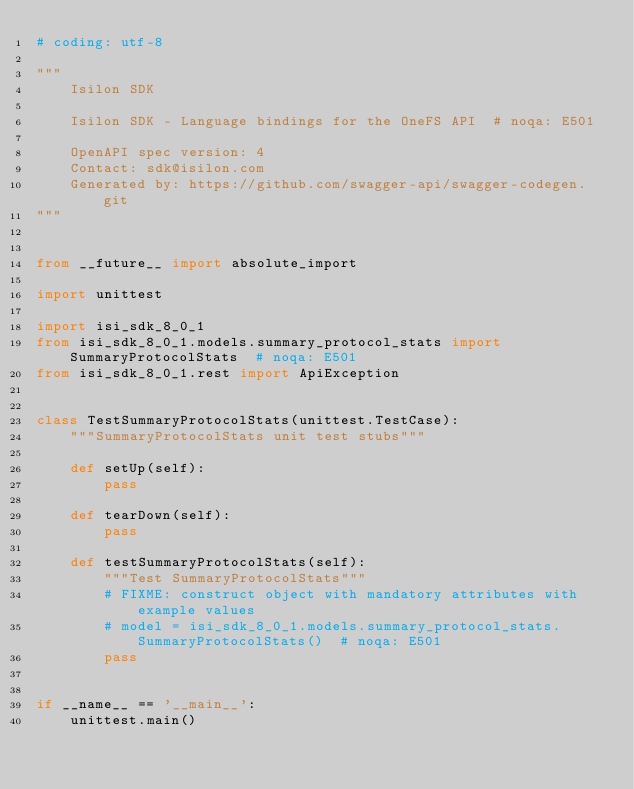Convert code to text. <code><loc_0><loc_0><loc_500><loc_500><_Python_># coding: utf-8

"""
    Isilon SDK

    Isilon SDK - Language bindings for the OneFS API  # noqa: E501

    OpenAPI spec version: 4
    Contact: sdk@isilon.com
    Generated by: https://github.com/swagger-api/swagger-codegen.git
"""


from __future__ import absolute_import

import unittest

import isi_sdk_8_0_1
from isi_sdk_8_0_1.models.summary_protocol_stats import SummaryProtocolStats  # noqa: E501
from isi_sdk_8_0_1.rest import ApiException


class TestSummaryProtocolStats(unittest.TestCase):
    """SummaryProtocolStats unit test stubs"""

    def setUp(self):
        pass

    def tearDown(self):
        pass

    def testSummaryProtocolStats(self):
        """Test SummaryProtocolStats"""
        # FIXME: construct object with mandatory attributes with example values
        # model = isi_sdk_8_0_1.models.summary_protocol_stats.SummaryProtocolStats()  # noqa: E501
        pass


if __name__ == '__main__':
    unittest.main()
</code> 